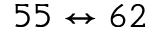<formula> <loc_0><loc_0><loc_500><loc_500>5 5 \leftrightarrow 6 2</formula> 